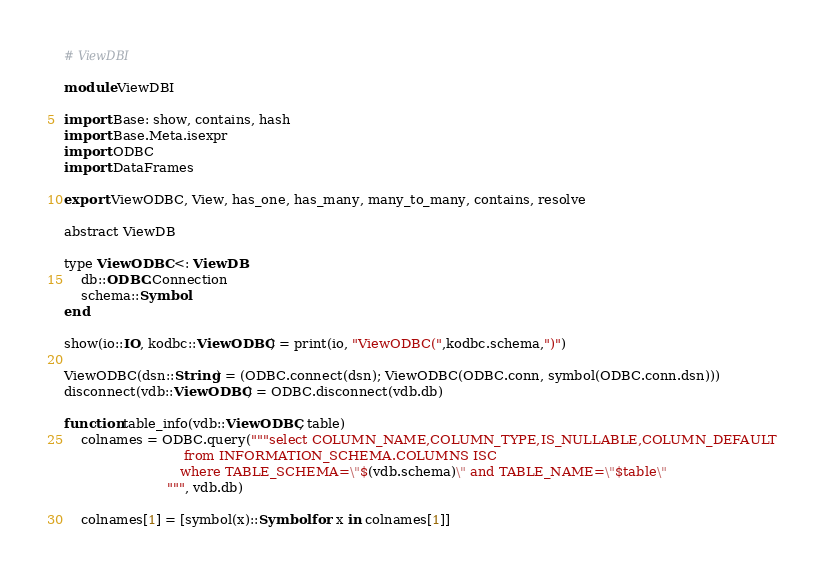<code> <loc_0><loc_0><loc_500><loc_500><_Julia_># ViewDBI

module ViewDBI

import Base: show, contains, hash
import Base.Meta.isexpr
import ODBC
import DataFrames

export ViewODBC, View, has_one, has_many, many_to_many, contains, resolve

abstract ViewDB

type ViewODBC <: ViewDB
    db::ODBC.Connection
    schema::Symbol
end

show(io::IO, kodbc::ViewODBC) = print(io, "ViewODBC(",kodbc.schema,")")

ViewODBC(dsn::String) = (ODBC.connect(dsn); ViewODBC(ODBC.conn, symbol(ODBC.conn.dsn)))
disconnect(vdb::ViewODBC) = ODBC.disconnect(vdb.db)

function table_info(vdb::ViewODBC, table)
    colnames = ODBC.query("""select COLUMN_NAME,COLUMN_TYPE,IS_NULLABLE,COLUMN_DEFAULT
                             from INFORMATION_SCHEMA.COLUMNS ISC 
                            where TABLE_SCHEMA=\"$(vdb.schema)\" and TABLE_NAME=\"$table\"
                         """, vdb.db)

    colnames[1] = [symbol(x)::Symbol for x in colnames[1]]
</code> 